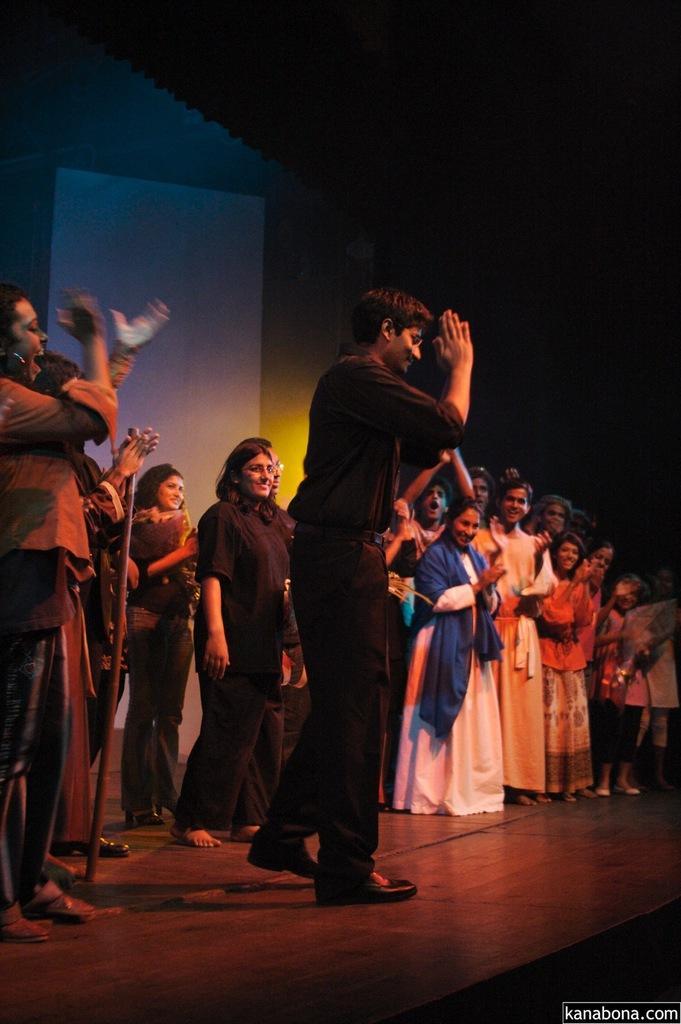Please provide a concise description of this image. In this image there are group of persons standing and smiling. In the background there is a curtain which is white in colour. 